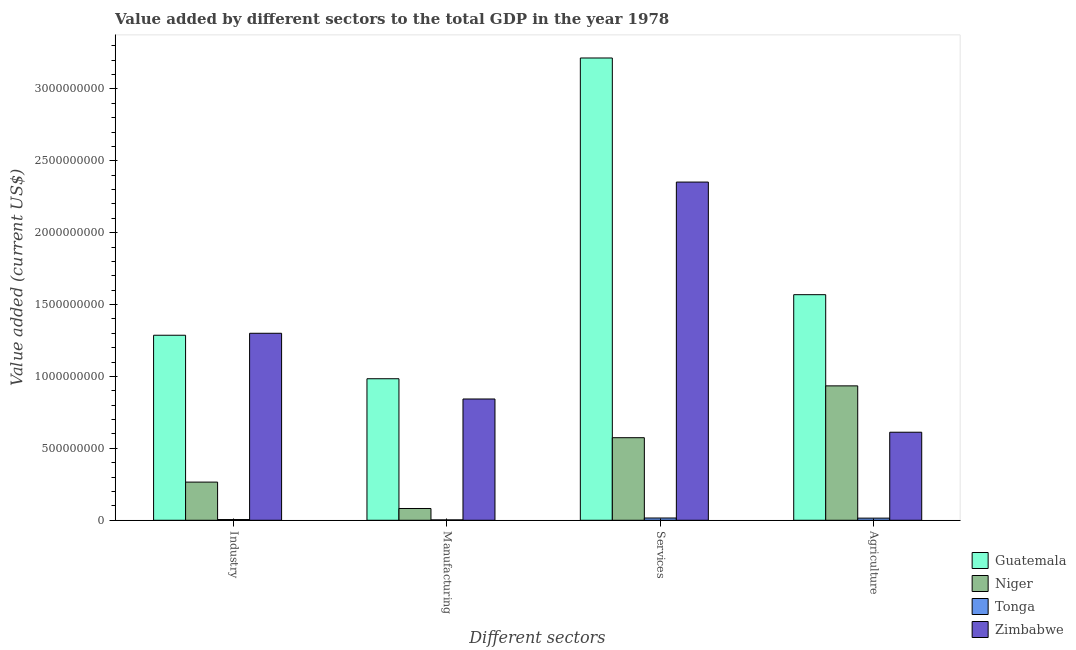Are the number of bars per tick equal to the number of legend labels?
Your answer should be very brief. Yes. Are the number of bars on each tick of the X-axis equal?
Give a very brief answer. Yes. How many bars are there on the 4th tick from the left?
Keep it short and to the point. 4. How many bars are there on the 4th tick from the right?
Ensure brevity in your answer.  4. What is the label of the 1st group of bars from the left?
Make the answer very short. Industry. What is the value added by manufacturing sector in Tonga?
Offer a very short reply. 2.64e+06. Across all countries, what is the maximum value added by manufacturing sector?
Keep it short and to the point. 9.84e+08. Across all countries, what is the minimum value added by services sector?
Your answer should be compact. 1.57e+07. In which country was the value added by manufacturing sector maximum?
Offer a very short reply. Guatemala. In which country was the value added by agricultural sector minimum?
Offer a very short reply. Tonga. What is the total value added by manufacturing sector in the graph?
Ensure brevity in your answer.  1.91e+09. What is the difference between the value added by agricultural sector in Zimbabwe and that in Tonga?
Make the answer very short. 5.97e+08. What is the difference between the value added by manufacturing sector in Zimbabwe and the value added by agricultural sector in Niger?
Keep it short and to the point. -9.13e+07. What is the average value added by manufacturing sector per country?
Give a very brief answer. 4.78e+08. What is the difference between the value added by industrial sector and value added by manufacturing sector in Niger?
Make the answer very short. 1.83e+08. In how many countries, is the value added by manufacturing sector greater than 600000000 US$?
Make the answer very short. 2. What is the ratio of the value added by services sector in Zimbabwe to that in Guatemala?
Offer a terse response. 0.73. Is the value added by services sector in Zimbabwe less than that in Tonga?
Make the answer very short. No. Is the difference between the value added by manufacturing sector in Niger and Guatemala greater than the difference between the value added by agricultural sector in Niger and Guatemala?
Offer a very short reply. No. What is the difference between the highest and the second highest value added by manufacturing sector?
Make the answer very short. 1.41e+08. What is the difference between the highest and the lowest value added by services sector?
Provide a short and direct response. 3.20e+09. What does the 3rd bar from the left in Agriculture represents?
Provide a short and direct response. Tonga. What does the 3rd bar from the right in Manufacturing represents?
Offer a very short reply. Niger. Is it the case that in every country, the sum of the value added by industrial sector and value added by manufacturing sector is greater than the value added by services sector?
Give a very brief answer. No. Are all the bars in the graph horizontal?
Your response must be concise. No. How many countries are there in the graph?
Make the answer very short. 4. Does the graph contain grids?
Offer a very short reply. No. How many legend labels are there?
Offer a very short reply. 4. How are the legend labels stacked?
Keep it short and to the point. Vertical. What is the title of the graph?
Make the answer very short. Value added by different sectors to the total GDP in the year 1978. Does "Korea (Republic)" appear as one of the legend labels in the graph?
Your response must be concise. No. What is the label or title of the X-axis?
Offer a very short reply. Different sectors. What is the label or title of the Y-axis?
Give a very brief answer. Value added (current US$). What is the Value added (current US$) in Guatemala in Industry?
Ensure brevity in your answer.  1.29e+09. What is the Value added (current US$) in Niger in Industry?
Provide a short and direct response. 2.65e+08. What is the Value added (current US$) in Tonga in Industry?
Your answer should be compact. 4.97e+06. What is the Value added (current US$) of Zimbabwe in Industry?
Ensure brevity in your answer.  1.30e+09. What is the Value added (current US$) of Guatemala in Manufacturing?
Your response must be concise. 9.84e+08. What is the Value added (current US$) of Niger in Manufacturing?
Your answer should be compact. 8.19e+07. What is the Value added (current US$) of Tonga in Manufacturing?
Keep it short and to the point. 2.64e+06. What is the Value added (current US$) of Zimbabwe in Manufacturing?
Your answer should be very brief. 8.43e+08. What is the Value added (current US$) in Guatemala in Services?
Provide a succinct answer. 3.21e+09. What is the Value added (current US$) in Niger in Services?
Your response must be concise. 5.74e+08. What is the Value added (current US$) of Tonga in Services?
Keep it short and to the point. 1.57e+07. What is the Value added (current US$) of Zimbabwe in Services?
Offer a terse response. 2.35e+09. What is the Value added (current US$) of Guatemala in Agriculture?
Offer a terse response. 1.57e+09. What is the Value added (current US$) in Niger in Agriculture?
Keep it short and to the point. 9.35e+08. What is the Value added (current US$) of Tonga in Agriculture?
Offer a terse response. 1.48e+07. What is the Value added (current US$) of Zimbabwe in Agriculture?
Your answer should be compact. 6.12e+08. Across all Different sectors, what is the maximum Value added (current US$) in Guatemala?
Ensure brevity in your answer.  3.21e+09. Across all Different sectors, what is the maximum Value added (current US$) of Niger?
Keep it short and to the point. 9.35e+08. Across all Different sectors, what is the maximum Value added (current US$) in Tonga?
Your response must be concise. 1.57e+07. Across all Different sectors, what is the maximum Value added (current US$) in Zimbabwe?
Give a very brief answer. 2.35e+09. Across all Different sectors, what is the minimum Value added (current US$) of Guatemala?
Give a very brief answer. 9.84e+08. Across all Different sectors, what is the minimum Value added (current US$) of Niger?
Provide a short and direct response. 8.19e+07. Across all Different sectors, what is the minimum Value added (current US$) in Tonga?
Give a very brief answer. 2.64e+06. Across all Different sectors, what is the minimum Value added (current US$) in Zimbabwe?
Keep it short and to the point. 6.12e+08. What is the total Value added (current US$) of Guatemala in the graph?
Provide a short and direct response. 7.05e+09. What is the total Value added (current US$) in Niger in the graph?
Give a very brief answer. 1.86e+09. What is the total Value added (current US$) of Tonga in the graph?
Your answer should be very brief. 3.81e+07. What is the total Value added (current US$) in Zimbabwe in the graph?
Provide a succinct answer. 5.11e+09. What is the difference between the Value added (current US$) in Guatemala in Industry and that in Manufacturing?
Give a very brief answer. 3.02e+08. What is the difference between the Value added (current US$) in Niger in Industry and that in Manufacturing?
Keep it short and to the point. 1.83e+08. What is the difference between the Value added (current US$) of Tonga in Industry and that in Manufacturing?
Ensure brevity in your answer.  2.33e+06. What is the difference between the Value added (current US$) of Zimbabwe in Industry and that in Manufacturing?
Offer a terse response. 4.57e+08. What is the difference between the Value added (current US$) of Guatemala in Industry and that in Services?
Offer a terse response. -1.93e+09. What is the difference between the Value added (current US$) of Niger in Industry and that in Services?
Make the answer very short. -3.09e+08. What is the difference between the Value added (current US$) of Tonga in Industry and that in Services?
Provide a succinct answer. -1.07e+07. What is the difference between the Value added (current US$) in Zimbabwe in Industry and that in Services?
Provide a succinct answer. -1.05e+09. What is the difference between the Value added (current US$) of Guatemala in Industry and that in Agriculture?
Keep it short and to the point. -2.82e+08. What is the difference between the Value added (current US$) of Niger in Industry and that in Agriculture?
Offer a terse response. -6.69e+08. What is the difference between the Value added (current US$) in Tonga in Industry and that in Agriculture?
Your response must be concise. -9.88e+06. What is the difference between the Value added (current US$) in Zimbabwe in Industry and that in Agriculture?
Offer a very short reply. 6.88e+08. What is the difference between the Value added (current US$) in Guatemala in Manufacturing and that in Services?
Keep it short and to the point. -2.23e+09. What is the difference between the Value added (current US$) in Niger in Manufacturing and that in Services?
Your answer should be compact. -4.92e+08. What is the difference between the Value added (current US$) in Tonga in Manufacturing and that in Services?
Ensure brevity in your answer.  -1.31e+07. What is the difference between the Value added (current US$) in Zimbabwe in Manufacturing and that in Services?
Your answer should be compact. -1.51e+09. What is the difference between the Value added (current US$) of Guatemala in Manufacturing and that in Agriculture?
Offer a very short reply. -5.85e+08. What is the difference between the Value added (current US$) of Niger in Manufacturing and that in Agriculture?
Your answer should be very brief. -8.53e+08. What is the difference between the Value added (current US$) of Tonga in Manufacturing and that in Agriculture?
Keep it short and to the point. -1.22e+07. What is the difference between the Value added (current US$) of Zimbabwe in Manufacturing and that in Agriculture?
Give a very brief answer. 2.31e+08. What is the difference between the Value added (current US$) of Guatemala in Services and that in Agriculture?
Keep it short and to the point. 1.65e+09. What is the difference between the Value added (current US$) in Niger in Services and that in Agriculture?
Your answer should be very brief. -3.61e+08. What is the difference between the Value added (current US$) of Tonga in Services and that in Agriculture?
Keep it short and to the point. 8.66e+05. What is the difference between the Value added (current US$) in Zimbabwe in Services and that in Agriculture?
Provide a short and direct response. 1.74e+09. What is the difference between the Value added (current US$) of Guatemala in Industry and the Value added (current US$) of Niger in Manufacturing?
Your response must be concise. 1.20e+09. What is the difference between the Value added (current US$) in Guatemala in Industry and the Value added (current US$) in Tonga in Manufacturing?
Offer a very short reply. 1.28e+09. What is the difference between the Value added (current US$) in Guatemala in Industry and the Value added (current US$) in Zimbabwe in Manufacturing?
Provide a succinct answer. 4.43e+08. What is the difference between the Value added (current US$) in Niger in Industry and the Value added (current US$) in Tonga in Manufacturing?
Keep it short and to the point. 2.63e+08. What is the difference between the Value added (current US$) in Niger in Industry and the Value added (current US$) in Zimbabwe in Manufacturing?
Provide a short and direct response. -5.78e+08. What is the difference between the Value added (current US$) in Tonga in Industry and the Value added (current US$) in Zimbabwe in Manufacturing?
Offer a very short reply. -8.38e+08. What is the difference between the Value added (current US$) in Guatemala in Industry and the Value added (current US$) in Niger in Services?
Your answer should be very brief. 7.13e+08. What is the difference between the Value added (current US$) of Guatemala in Industry and the Value added (current US$) of Tonga in Services?
Give a very brief answer. 1.27e+09. What is the difference between the Value added (current US$) in Guatemala in Industry and the Value added (current US$) in Zimbabwe in Services?
Ensure brevity in your answer.  -1.07e+09. What is the difference between the Value added (current US$) in Niger in Industry and the Value added (current US$) in Tonga in Services?
Your answer should be very brief. 2.50e+08. What is the difference between the Value added (current US$) in Niger in Industry and the Value added (current US$) in Zimbabwe in Services?
Provide a succinct answer. -2.09e+09. What is the difference between the Value added (current US$) in Tonga in Industry and the Value added (current US$) in Zimbabwe in Services?
Give a very brief answer. -2.35e+09. What is the difference between the Value added (current US$) in Guatemala in Industry and the Value added (current US$) in Niger in Agriculture?
Your response must be concise. 3.52e+08. What is the difference between the Value added (current US$) of Guatemala in Industry and the Value added (current US$) of Tonga in Agriculture?
Keep it short and to the point. 1.27e+09. What is the difference between the Value added (current US$) in Guatemala in Industry and the Value added (current US$) in Zimbabwe in Agriculture?
Provide a short and direct response. 6.75e+08. What is the difference between the Value added (current US$) of Niger in Industry and the Value added (current US$) of Tonga in Agriculture?
Keep it short and to the point. 2.51e+08. What is the difference between the Value added (current US$) in Niger in Industry and the Value added (current US$) in Zimbabwe in Agriculture?
Make the answer very short. -3.47e+08. What is the difference between the Value added (current US$) in Tonga in Industry and the Value added (current US$) in Zimbabwe in Agriculture?
Provide a succinct answer. -6.07e+08. What is the difference between the Value added (current US$) in Guatemala in Manufacturing and the Value added (current US$) in Niger in Services?
Your answer should be very brief. 4.10e+08. What is the difference between the Value added (current US$) in Guatemala in Manufacturing and the Value added (current US$) in Tonga in Services?
Provide a short and direct response. 9.69e+08. What is the difference between the Value added (current US$) of Guatemala in Manufacturing and the Value added (current US$) of Zimbabwe in Services?
Your answer should be very brief. -1.37e+09. What is the difference between the Value added (current US$) of Niger in Manufacturing and the Value added (current US$) of Tonga in Services?
Provide a short and direct response. 6.62e+07. What is the difference between the Value added (current US$) in Niger in Manufacturing and the Value added (current US$) in Zimbabwe in Services?
Offer a terse response. -2.27e+09. What is the difference between the Value added (current US$) in Tonga in Manufacturing and the Value added (current US$) in Zimbabwe in Services?
Give a very brief answer. -2.35e+09. What is the difference between the Value added (current US$) of Guatemala in Manufacturing and the Value added (current US$) of Niger in Agriculture?
Provide a succinct answer. 4.95e+07. What is the difference between the Value added (current US$) in Guatemala in Manufacturing and the Value added (current US$) in Tonga in Agriculture?
Give a very brief answer. 9.69e+08. What is the difference between the Value added (current US$) in Guatemala in Manufacturing and the Value added (current US$) in Zimbabwe in Agriculture?
Keep it short and to the point. 3.72e+08. What is the difference between the Value added (current US$) of Niger in Manufacturing and the Value added (current US$) of Tonga in Agriculture?
Your answer should be very brief. 6.71e+07. What is the difference between the Value added (current US$) of Niger in Manufacturing and the Value added (current US$) of Zimbabwe in Agriculture?
Your response must be concise. -5.30e+08. What is the difference between the Value added (current US$) in Tonga in Manufacturing and the Value added (current US$) in Zimbabwe in Agriculture?
Provide a succinct answer. -6.10e+08. What is the difference between the Value added (current US$) in Guatemala in Services and the Value added (current US$) in Niger in Agriculture?
Give a very brief answer. 2.28e+09. What is the difference between the Value added (current US$) of Guatemala in Services and the Value added (current US$) of Tonga in Agriculture?
Provide a short and direct response. 3.20e+09. What is the difference between the Value added (current US$) in Guatemala in Services and the Value added (current US$) in Zimbabwe in Agriculture?
Provide a succinct answer. 2.60e+09. What is the difference between the Value added (current US$) of Niger in Services and the Value added (current US$) of Tonga in Agriculture?
Ensure brevity in your answer.  5.59e+08. What is the difference between the Value added (current US$) of Niger in Services and the Value added (current US$) of Zimbabwe in Agriculture?
Your response must be concise. -3.80e+07. What is the difference between the Value added (current US$) in Tonga in Services and the Value added (current US$) in Zimbabwe in Agriculture?
Provide a succinct answer. -5.97e+08. What is the average Value added (current US$) of Guatemala per Different sectors?
Your answer should be very brief. 1.76e+09. What is the average Value added (current US$) of Niger per Different sectors?
Make the answer very short. 4.64e+08. What is the average Value added (current US$) in Tonga per Different sectors?
Ensure brevity in your answer.  9.54e+06. What is the average Value added (current US$) of Zimbabwe per Different sectors?
Offer a very short reply. 1.28e+09. What is the difference between the Value added (current US$) of Guatemala and Value added (current US$) of Niger in Industry?
Keep it short and to the point. 1.02e+09. What is the difference between the Value added (current US$) in Guatemala and Value added (current US$) in Tonga in Industry?
Ensure brevity in your answer.  1.28e+09. What is the difference between the Value added (current US$) of Guatemala and Value added (current US$) of Zimbabwe in Industry?
Provide a succinct answer. -1.38e+07. What is the difference between the Value added (current US$) in Niger and Value added (current US$) in Tonga in Industry?
Your answer should be compact. 2.60e+08. What is the difference between the Value added (current US$) of Niger and Value added (current US$) of Zimbabwe in Industry?
Make the answer very short. -1.04e+09. What is the difference between the Value added (current US$) in Tonga and Value added (current US$) in Zimbabwe in Industry?
Provide a short and direct response. -1.30e+09. What is the difference between the Value added (current US$) in Guatemala and Value added (current US$) in Niger in Manufacturing?
Give a very brief answer. 9.02e+08. What is the difference between the Value added (current US$) of Guatemala and Value added (current US$) of Tonga in Manufacturing?
Your answer should be very brief. 9.82e+08. What is the difference between the Value added (current US$) of Guatemala and Value added (current US$) of Zimbabwe in Manufacturing?
Keep it short and to the point. 1.41e+08. What is the difference between the Value added (current US$) of Niger and Value added (current US$) of Tonga in Manufacturing?
Offer a terse response. 7.93e+07. What is the difference between the Value added (current US$) of Niger and Value added (current US$) of Zimbabwe in Manufacturing?
Ensure brevity in your answer.  -7.62e+08. What is the difference between the Value added (current US$) in Tonga and Value added (current US$) in Zimbabwe in Manufacturing?
Offer a very short reply. -8.41e+08. What is the difference between the Value added (current US$) in Guatemala and Value added (current US$) in Niger in Services?
Your response must be concise. 2.64e+09. What is the difference between the Value added (current US$) of Guatemala and Value added (current US$) of Tonga in Services?
Your answer should be compact. 3.20e+09. What is the difference between the Value added (current US$) of Guatemala and Value added (current US$) of Zimbabwe in Services?
Your answer should be compact. 8.63e+08. What is the difference between the Value added (current US$) of Niger and Value added (current US$) of Tonga in Services?
Give a very brief answer. 5.59e+08. What is the difference between the Value added (current US$) in Niger and Value added (current US$) in Zimbabwe in Services?
Your response must be concise. -1.78e+09. What is the difference between the Value added (current US$) in Tonga and Value added (current US$) in Zimbabwe in Services?
Offer a very short reply. -2.34e+09. What is the difference between the Value added (current US$) of Guatemala and Value added (current US$) of Niger in Agriculture?
Offer a very short reply. 6.34e+08. What is the difference between the Value added (current US$) in Guatemala and Value added (current US$) in Tonga in Agriculture?
Keep it short and to the point. 1.55e+09. What is the difference between the Value added (current US$) in Guatemala and Value added (current US$) in Zimbabwe in Agriculture?
Your answer should be compact. 9.57e+08. What is the difference between the Value added (current US$) of Niger and Value added (current US$) of Tonga in Agriculture?
Make the answer very short. 9.20e+08. What is the difference between the Value added (current US$) of Niger and Value added (current US$) of Zimbabwe in Agriculture?
Ensure brevity in your answer.  3.23e+08. What is the difference between the Value added (current US$) in Tonga and Value added (current US$) in Zimbabwe in Agriculture?
Ensure brevity in your answer.  -5.97e+08. What is the ratio of the Value added (current US$) in Guatemala in Industry to that in Manufacturing?
Your response must be concise. 1.31. What is the ratio of the Value added (current US$) of Niger in Industry to that in Manufacturing?
Provide a succinct answer. 3.24. What is the ratio of the Value added (current US$) in Tonga in Industry to that in Manufacturing?
Give a very brief answer. 1.88. What is the ratio of the Value added (current US$) in Zimbabwe in Industry to that in Manufacturing?
Ensure brevity in your answer.  1.54. What is the ratio of the Value added (current US$) in Guatemala in Industry to that in Services?
Your answer should be very brief. 0.4. What is the ratio of the Value added (current US$) of Niger in Industry to that in Services?
Offer a very short reply. 0.46. What is the ratio of the Value added (current US$) of Tonga in Industry to that in Services?
Your response must be concise. 0.32. What is the ratio of the Value added (current US$) in Zimbabwe in Industry to that in Services?
Offer a very short reply. 0.55. What is the ratio of the Value added (current US$) of Guatemala in Industry to that in Agriculture?
Your response must be concise. 0.82. What is the ratio of the Value added (current US$) in Niger in Industry to that in Agriculture?
Keep it short and to the point. 0.28. What is the ratio of the Value added (current US$) in Tonga in Industry to that in Agriculture?
Offer a very short reply. 0.33. What is the ratio of the Value added (current US$) in Zimbabwe in Industry to that in Agriculture?
Offer a terse response. 2.12. What is the ratio of the Value added (current US$) of Guatemala in Manufacturing to that in Services?
Your response must be concise. 0.31. What is the ratio of the Value added (current US$) in Niger in Manufacturing to that in Services?
Make the answer very short. 0.14. What is the ratio of the Value added (current US$) in Tonga in Manufacturing to that in Services?
Offer a very short reply. 0.17. What is the ratio of the Value added (current US$) in Zimbabwe in Manufacturing to that in Services?
Provide a succinct answer. 0.36. What is the ratio of the Value added (current US$) in Guatemala in Manufacturing to that in Agriculture?
Provide a short and direct response. 0.63. What is the ratio of the Value added (current US$) in Niger in Manufacturing to that in Agriculture?
Ensure brevity in your answer.  0.09. What is the ratio of the Value added (current US$) in Tonga in Manufacturing to that in Agriculture?
Your answer should be compact. 0.18. What is the ratio of the Value added (current US$) of Zimbabwe in Manufacturing to that in Agriculture?
Your answer should be compact. 1.38. What is the ratio of the Value added (current US$) of Guatemala in Services to that in Agriculture?
Offer a very short reply. 2.05. What is the ratio of the Value added (current US$) of Niger in Services to that in Agriculture?
Keep it short and to the point. 0.61. What is the ratio of the Value added (current US$) of Tonga in Services to that in Agriculture?
Keep it short and to the point. 1.06. What is the ratio of the Value added (current US$) in Zimbabwe in Services to that in Agriculture?
Your answer should be compact. 3.84. What is the difference between the highest and the second highest Value added (current US$) in Guatemala?
Provide a succinct answer. 1.65e+09. What is the difference between the highest and the second highest Value added (current US$) in Niger?
Your answer should be very brief. 3.61e+08. What is the difference between the highest and the second highest Value added (current US$) in Tonga?
Offer a terse response. 8.66e+05. What is the difference between the highest and the second highest Value added (current US$) of Zimbabwe?
Offer a very short reply. 1.05e+09. What is the difference between the highest and the lowest Value added (current US$) of Guatemala?
Ensure brevity in your answer.  2.23e+09. What is the difference between the highest and the lowest Value added (current US$) of Niger?
Keep it short and to the point. 8.53e+08. What is the difference between the highest and the lowest Value added (current US$) in Tonga?
Offer a terse response. 1.31e+07. What is the difference between the highest and the lowest Value added (current US$) of Zimbabwe?
Offer a very short reply. 1.74e+09. 